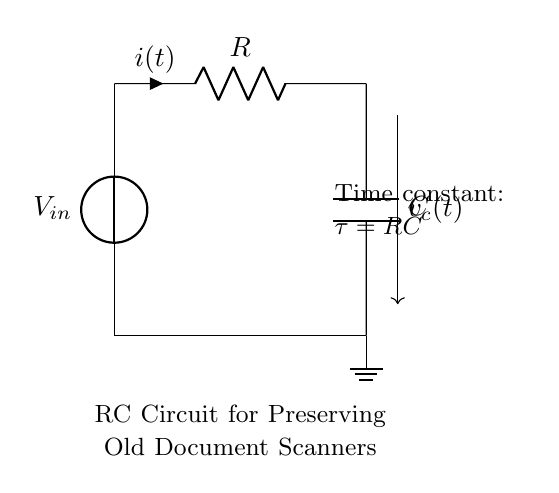What is the type of this circuit? This circuit is an RC circuit, characterized by the presence of a resistor and a capacitor. The layout demonstrates their connection and function in a circuit used for preserving old document scanners.
Answer: RC circuit What does the symbol "R" represent? The symbol "R" on the diagram represents the resistor component of the circuit. It is crucial for managing the current flow within the circuit.
Answer: Resistor What does the symbol "C" represent? The symbol "C" in the circuit diagram denotes the capacitor. It is essential for storing electrical energy and influencing how the circuit reacts to changes in voltage.
Answer: Capacitor What is the time constant for this circuit? The time constant, denoted by the symbol tau, is the product of resistance and capacitance, expressed as tau equals R times C. This measures how quickly the system responds to changes.
Answer: tau = RC How does the current behave over time in this circuit? In an RC circuit, the current starts at its maximum value and then decreases exponentially over time towards zero as the capacitor charges. This exponential decline characterizes charging in RC circuits.
Answer: Exponentially decreasing What happens to the voltage across the capacitor as time progresses? As time progresses, the voltage across the capacitor increases and approaches the input voltage, following an exponential growth until the capacitor is fully charged. This relationship is key to understanding capacitor behavior in circuits.
Answer: Increases to input voltage What is the role of the resistor in this circuit regarding preservation? The resistor in this RC circuit limits the current flow, which is vital for protecting delicate components, such as those in document scanners, by preventing excessive current that could cause damage.
Answer: Limits current flow 